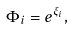Convert formula to latex. <formula><loc_0><loc_0><loc_500><loc_500>\Phi _ { i } = e ^ { \xi _ { i } } ,</formula> 